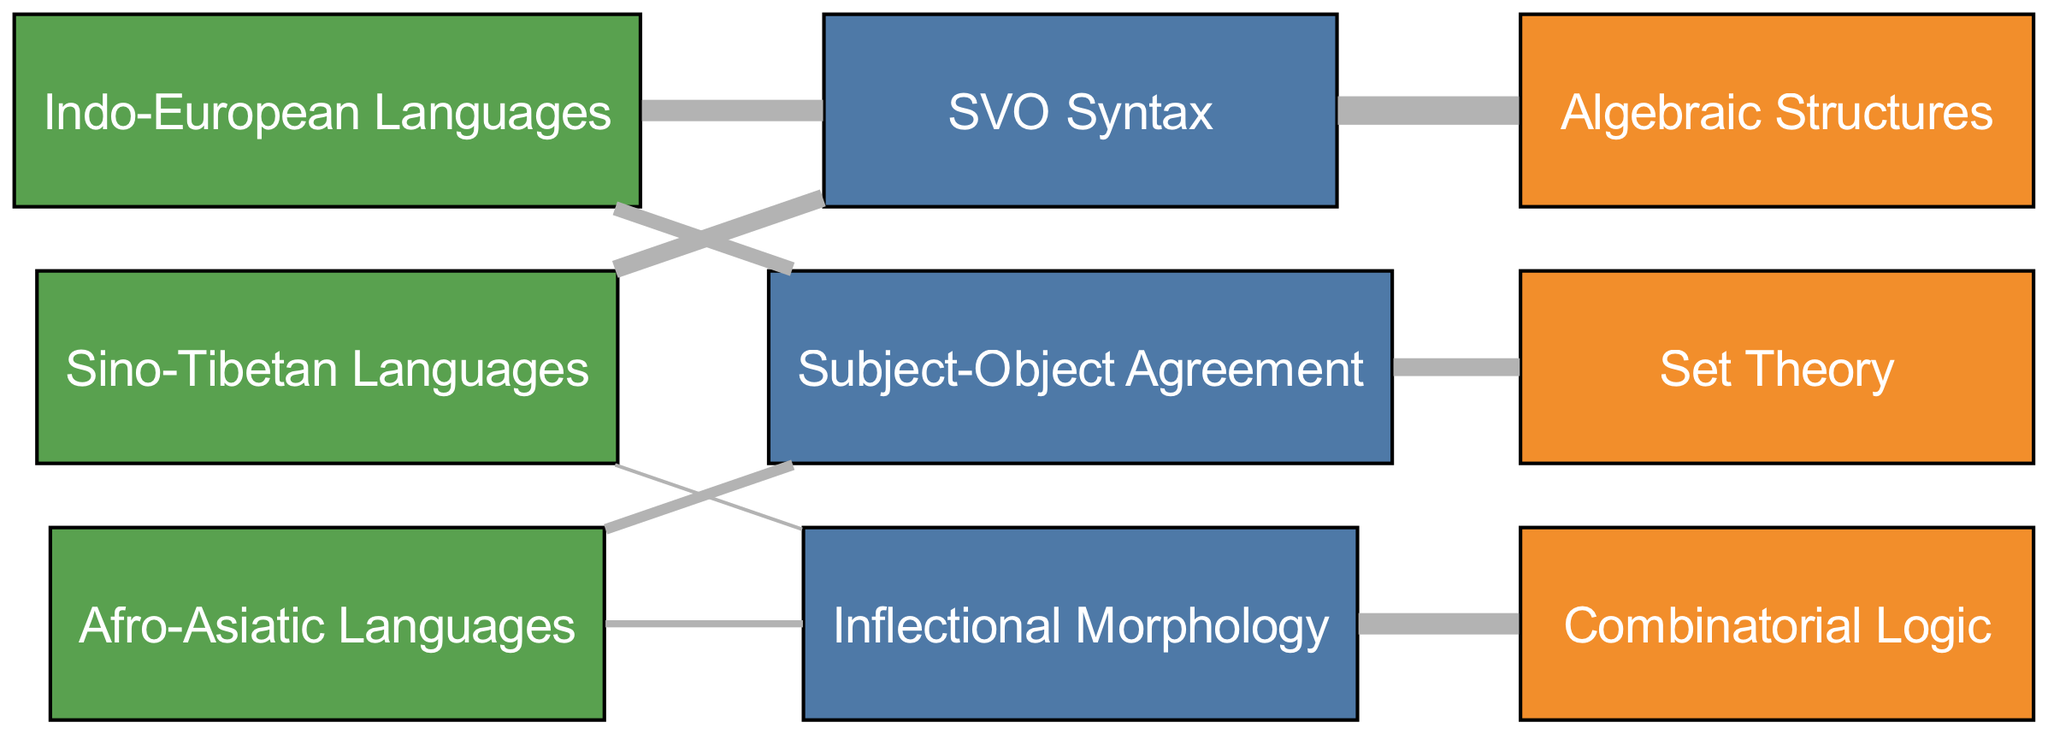What is the total number of linguistic features represented in the diagram? The diagram shows three nodes categorized as linguistic features: SVO Syntax, Subject-Object Agreement, and Inflectional Morphology. Therefore, the total is counted directly from the nodes.
Answer: 3 Which mathematical function is most connected to the SVO Syntax? The SVO Syntax node has a link with a value of 40 leading to Algebraic Structures. This is the highest value among the connections from SVO Syntax.
Answer: Algebraic Structures How many edges originate from the Afro-Asiatic Languages? By reviewing the links, we can see that there are two edges originating from the Afro-Asiatic Languages: one to Subject-Object Agreement and another to Inflectional Morphology. This counts directly from the connections.
Answer: 2 What is the value associated with the link between Subject-Object Agreement and Set Theory? The link from Subject-Object Agreement to Set Theory has a value of 25 as indicated in the connections provided. This is a straightforward observation of the link's value.
Answer: 25 Which language family has the least amount of linguistic features associated with it? By examining the links, the Sino-Tibetan Languages only connect to SVO Syntax and Inflectional Morphology, with a lesser total involving only one strong feature (5 for Inflectional Morphology). In contrast, others have more connections and values.
Answer: Sino-Tibetan Languages Is there a direct flow from Inflectional Morphology to any mathematical function, and if so, what is it? Yes, there is a direct flow from Inflectional Morphology to Combinatorial Logic with a value of 30. This can be traced directly from the link data.
Answer: Combinatorial Logic What is the total flow value originating from the Indo-European Languages? Adding the values from the Indo-European Languages links (30 to SVO Syntax and 20 to Subject-Object Agreement), we get 30 + 20 = 50. This involves summing the values linked to that node.
Answer: 50 Which linguistic feature has the lowest connection value, and what is that value? Inflectional Morphology has the lowest connection value of 5, linking to Sino-Tibetan languages. This is determined by comparing all link values associated with each linguistic feature.
Answer: 5 What type of diagram is presented, and what does it depict? The diagram is a Sankey Diagram, which depicts the flow of linguistic features across different language families and their correlation with mathematical functions. This description encompasses the purpose of the diagram type.
Answer: Sankey Diagram 